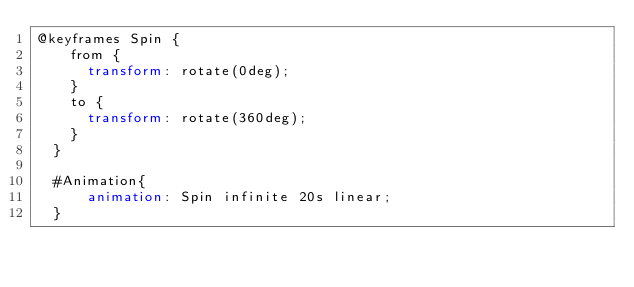Convert code to text. <code><loc_0><loc_0><loc_500><loc_500><_CSS_>@keyframes Spin {
    from {
      transform: rotate(0deg);
    }
    to {
      transform: rotate(360deg);
    }
  }

  #Animation{
      animation: Spin infinite 20s linear;
  }</code> 